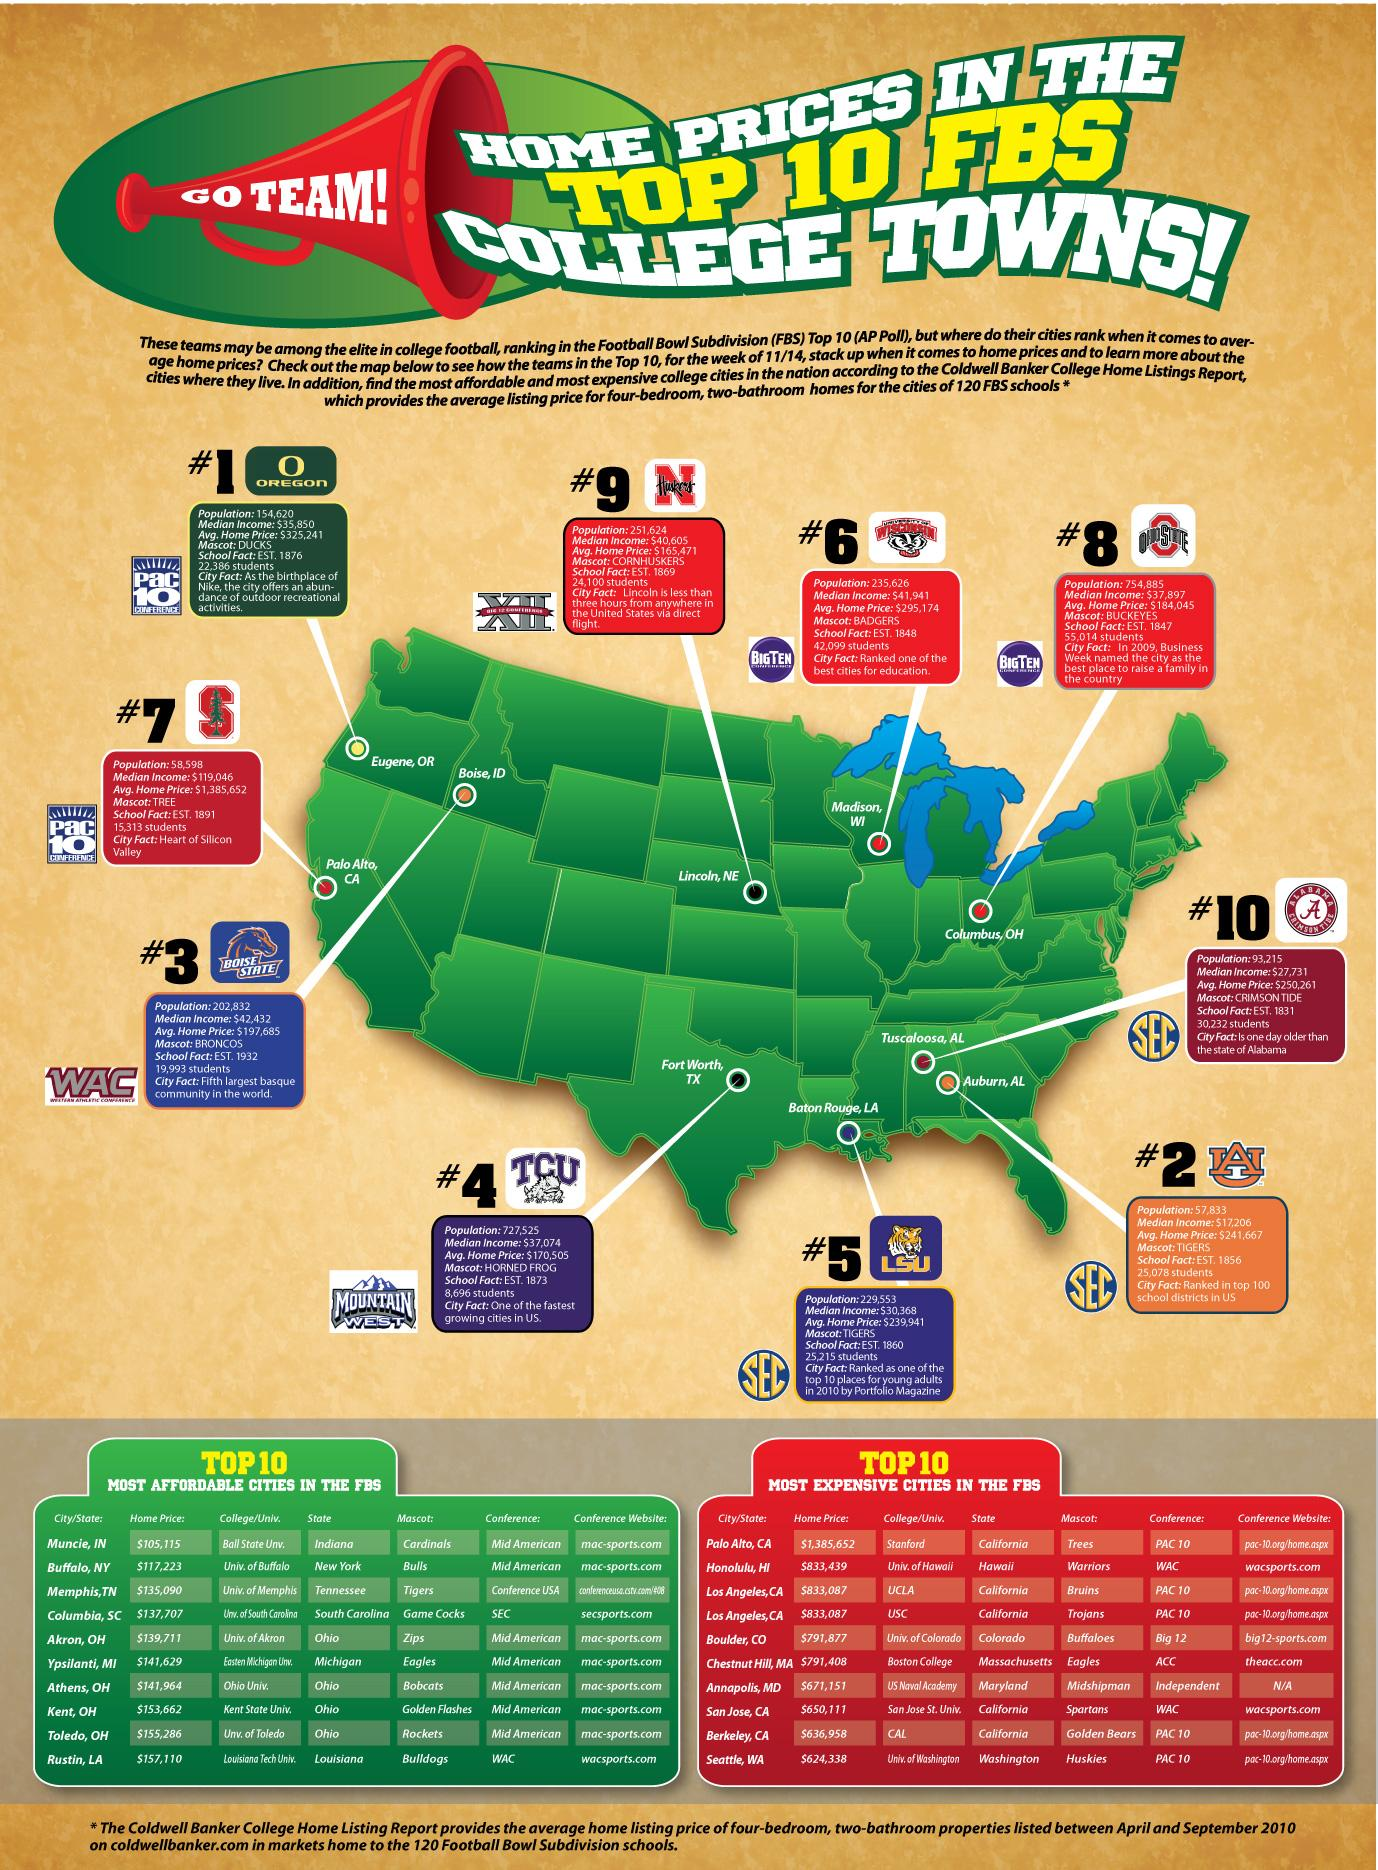Identify some key points in this picture. Four cities from California are listed as the most expensive cities in the Football Bowl Subdivision (FBS). The mascot of the football team at Ohio State University is buckeyes. The N Huskers, the University of Wisconsin, and Ohio State all have mascots that are associated with buckeyes. However, Ohio State's mascot is buckeyes. The average difference in the price of houses between the top 10 college cities and the number one city is approximately $74,980. The third row and third column of the university list features a mascot named Bruins. TCU, a football team based in Texas, is the correct answer. 